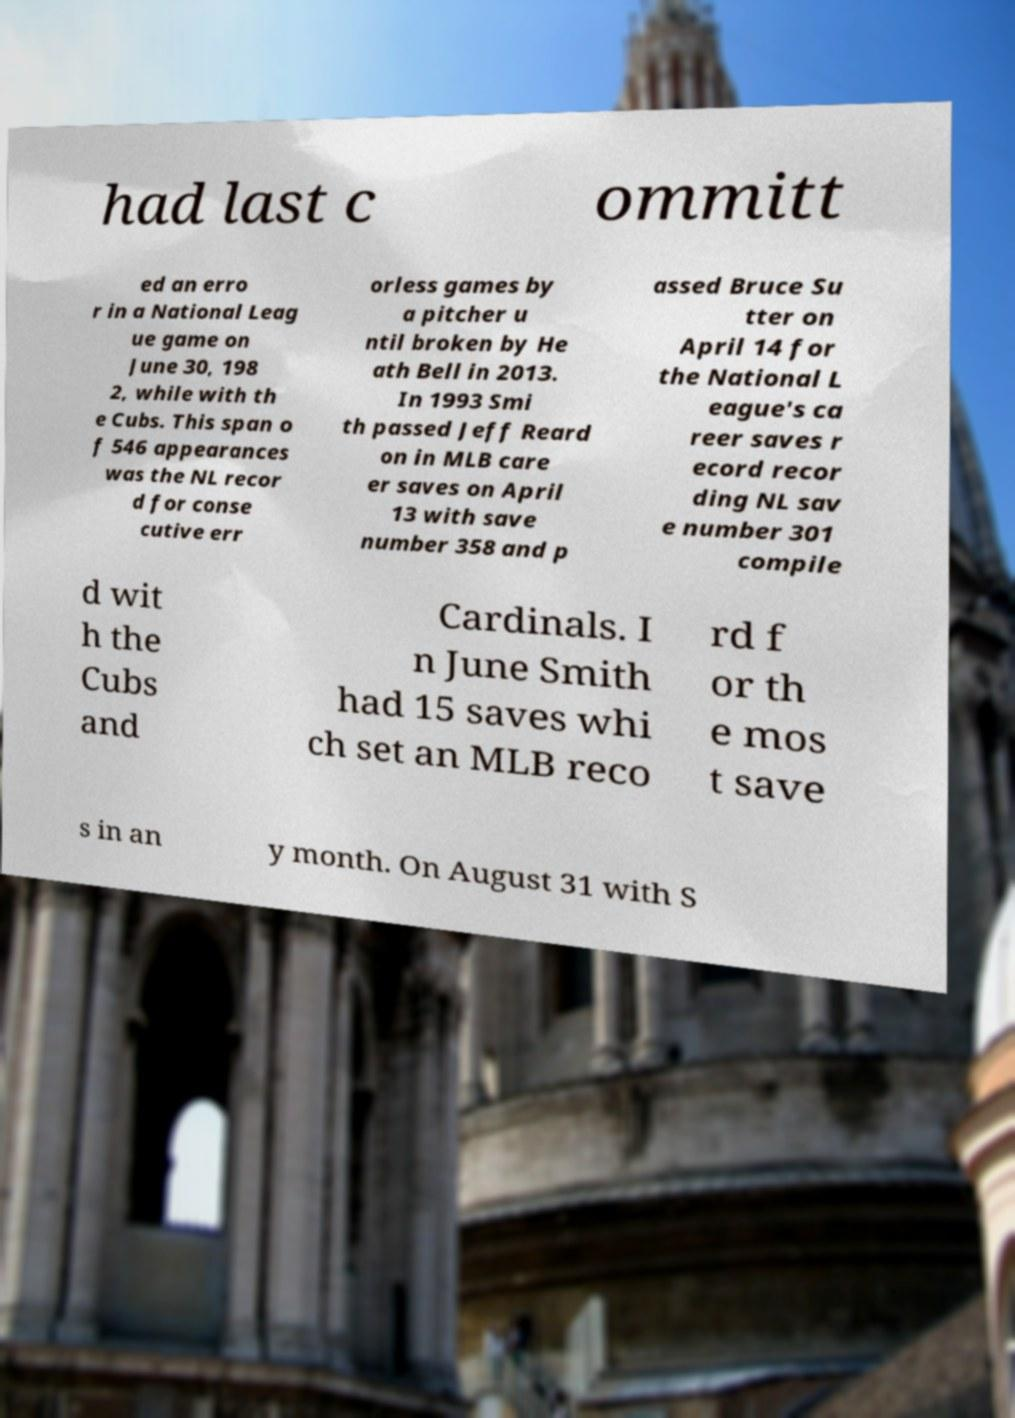Can you read and provide the text displayed in the image?This photo seems to have some interesting text. Can you extract and type it out for me? had last c ommitt ed an erro r in a National Leag ue game on June 30, 198 2, while with th e Cubs. This span o f 546 appearances was the NL recor d for conse cutive err orless games by a pitcher u ntil broken by He ath Bell in 2013. In 1993 Smi th passed Jeff Reard on in MLB care er saves on April 13 with save number 358 and p assed Bruce Su tter on April 14 for the National L eague's ca reer saves r ecord recor ding NL sav e number 301 compile d wit h the Cubs and Cardinals. I n June Smith had 15 saves whi ch set an MLB reco rd f or th e mos t save s in an y month. On August 31 with S 